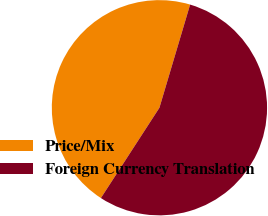Convert chart. <chart><loc_0><loc_0><loc_500><loc_500><pie_chart><fcel>Price/Mix<fcel>Foreign Currency Translation<nl><fcel>45.45%<fcel>54.55%<nl></chart> 